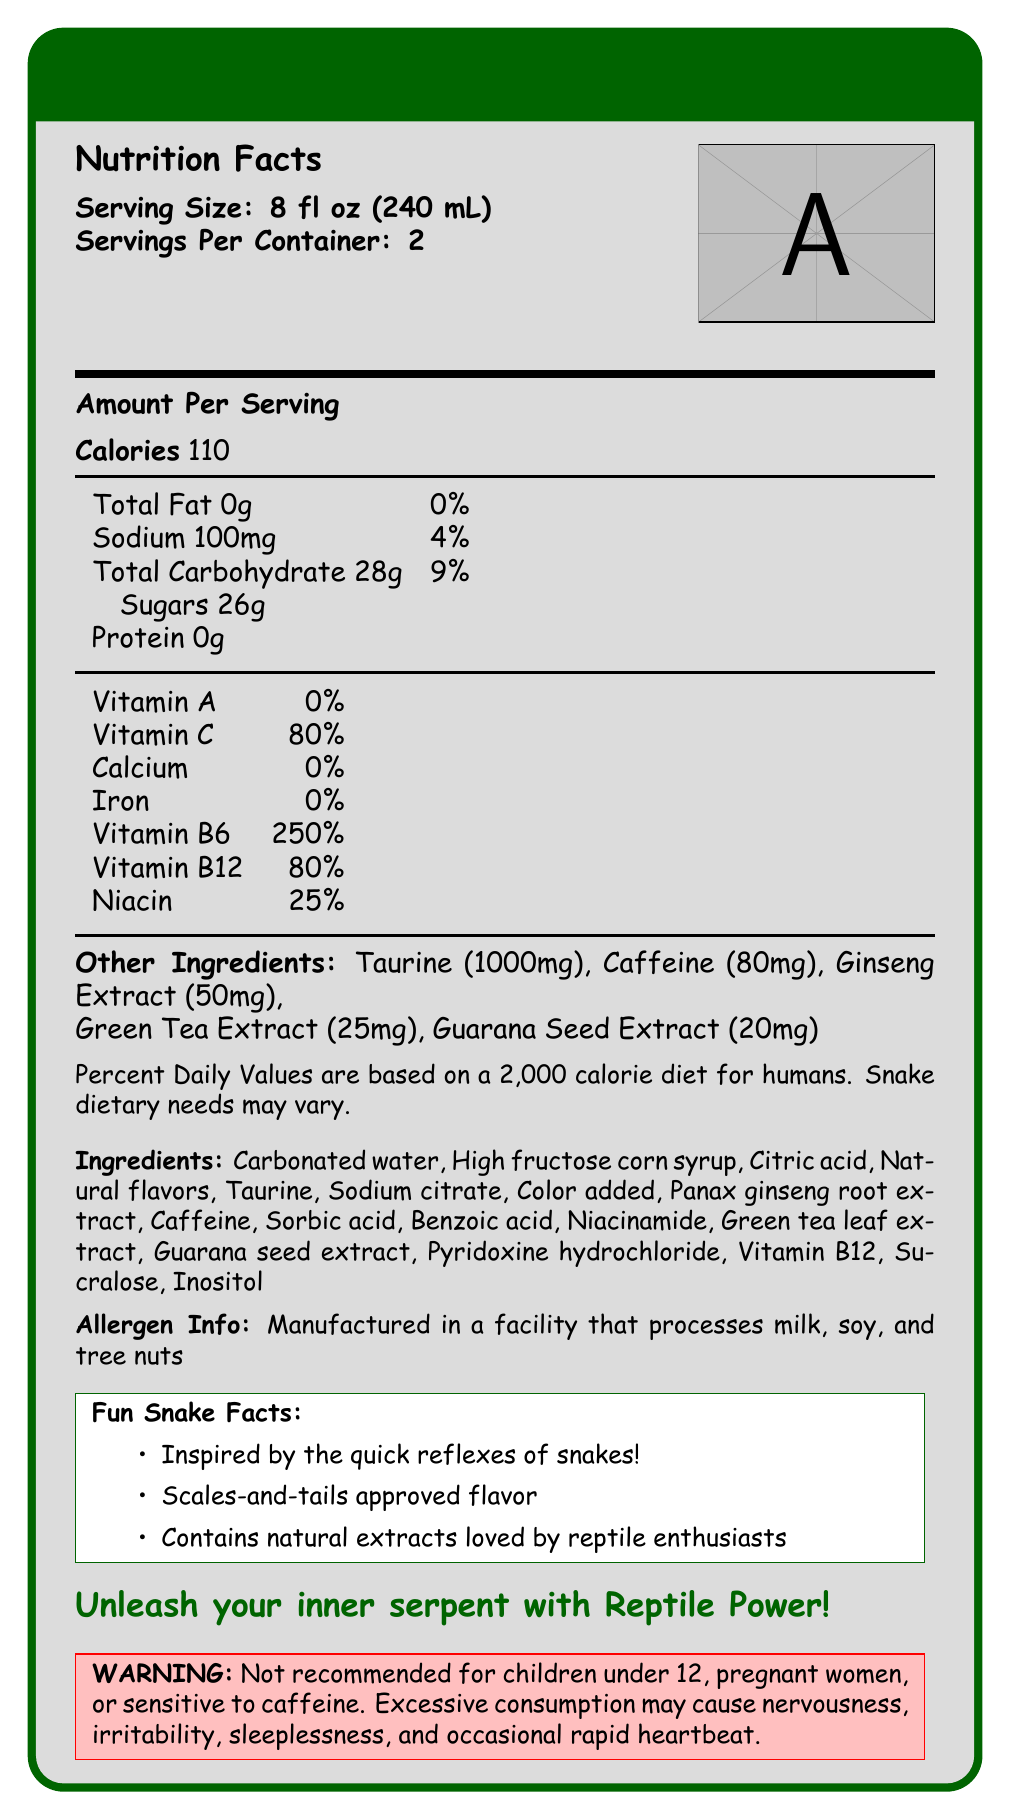What is the serving size for Reptile Power Energy Drink? The document states that the serving size is 8 fl oz (240 mL).
Answer: 8 fl oz (240 mL) How many servings are there per container? The document mentions that there are 2 servings per container.
Answer: 2 How many calories are there per serving? The Nutrition Facts section specifies that there are 110 calories per serving.
Answer: 110 What is the amount of sodium in one serving? The document lists 100 mg of sodium per serving.
Answer: 100 mg How much sugar is in each serving? The Nutritional Facts section shows that each serving has 26g of sugars.
Answer: 26g Which vitamin is present at the highest percentage of the Daily Value? Vitamin B6 is listed at 250% of the Daily Value, the highest among the vitamins listed.
Answer: Vitamin B6 Which of the following ingredients is not listed in the Reptile Power Energy Drink? A. High fructose corn syrup B. Carbonated water C. Vitamin D D. Sorbic acid Vitamin D is not included in the list of ingredients.
Answer: C. Vitamin D What is the amount of caffeine per serving in the Reptile Power Energy Drink? A. 20mg B. 50mg C. 80mg D. 100mg The document lists caffeine in the amount of 80mg per serving.
Answer: C. 80mg Is the drink suitable for children under 12? The warning section specifically mentions that it is not recommended for children under 12.
Answer: No Summarize the main marketing slogan for Reptile Power Energy Drink. The document provides this slogan as the main marketing tagline.
Answer: Unleash your inner serpent with Reptile Power! What daily diet is the Percent Daily Value based on? The document notes that the Percent Daily Values are based on a 2,000 calorie diet for humans.
Answer: 2,000 calorie diet for humans What are some fun facts about Reptile Power Energy Drink? These fun facts are listed in a specific section within the document.
Answer: Inspired by the quick reflexes of snakes, Scales-and-tails approved flavor, Contains natural extracts loved by reptile enthusiasts What facility allergen information is provided for this product? The document provides an allergen warning about the facility.
Answer: Manufactured in a facility that processes milk, soy, and tree nuts What is the main reason a pregnant woman should avoid drinking Reptile Power Energy Drink? The warning specifies that pregnant women should avoid it due to its caffeine content.
Answer: Caffeine content How much taurine is included in one serving of Reptile Power Energy Drink? The document states that there is 1000mg of taurine per serving.
Answer: 1000mg What is the main flavor inspiration for Reptile Power Energy Drink according to the fun facts? The document states that the flavor is inspired by the quick reflexes of snakes.
Answer: Quick reflexes of snakes What ingredient provides the sweet taste in Reptile Power Energy Drink? High fructose corn syrup is listed as one of the ingredients, contributing to the sweet taste.
Answer: High fructose corn syrup What is the percentage of Vitamin B12 in one serving? The document lists the Daily Value of Vitamin B12 at 80%.
Answer: 80% What is the color of the product's branding and box frame? The document uses the color "reptile green" for the branding and box frame.
Answer: Reptile green How can consuming Reptile Power Energy Drink affect sleep? The warning mentions that excessive consumption may result in sleeplessness.
Answer: It may cause sleeplessness What is the primary benefit of the ginseng extract in the drink? The document lists ginseng extract as an ingredient but does not detail its specific benefits or effects.
Answer: Not enough information 